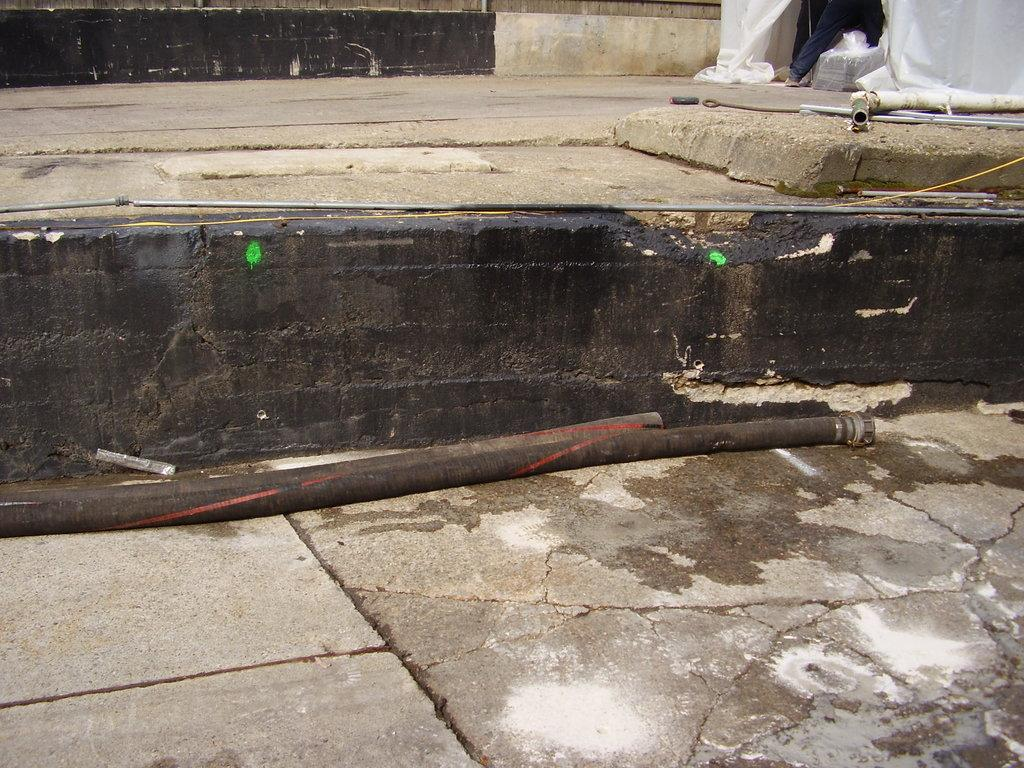What objects are present in the image? There are two pipes in the image. Can you describe the person in the image? There is a person standing at the right top most of the image. What type of rabbit can be seen wearing a shirt and stockings in the image? There is no rabbit present in the image, nor is there any reference to clothing items like a shirt or stockings. 